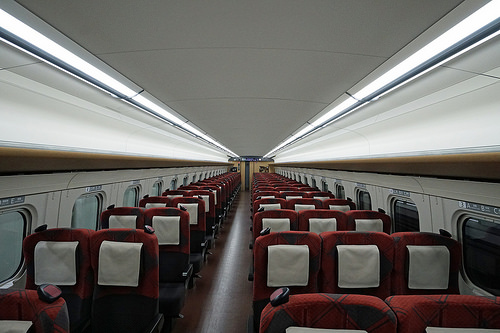<image>
Can you confirm if the window is to the left of the window? Yes. From this viewpoint, the window is positioned to the left side relative to the window. 